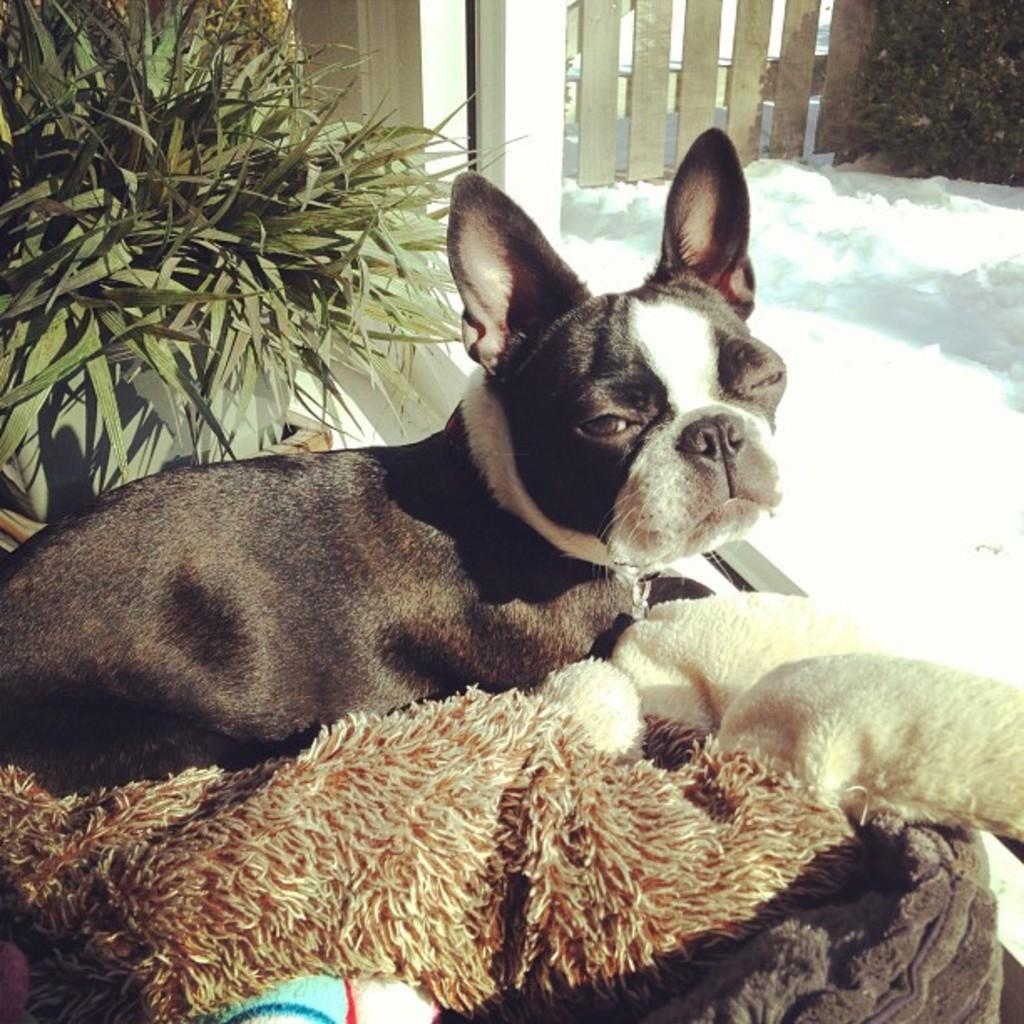What type of living organism can be seen in the image? There is an animal in the image. What other type of living organism can be seen in the image? There is a plant in the image. What is the purpose of the fence in the image? The fence in the image serves as a barrier or boundary. What religion is the animal practicing in the image? There is no indication of any religious practice in the image, as it features an animal, a plant, and a fence. --- 